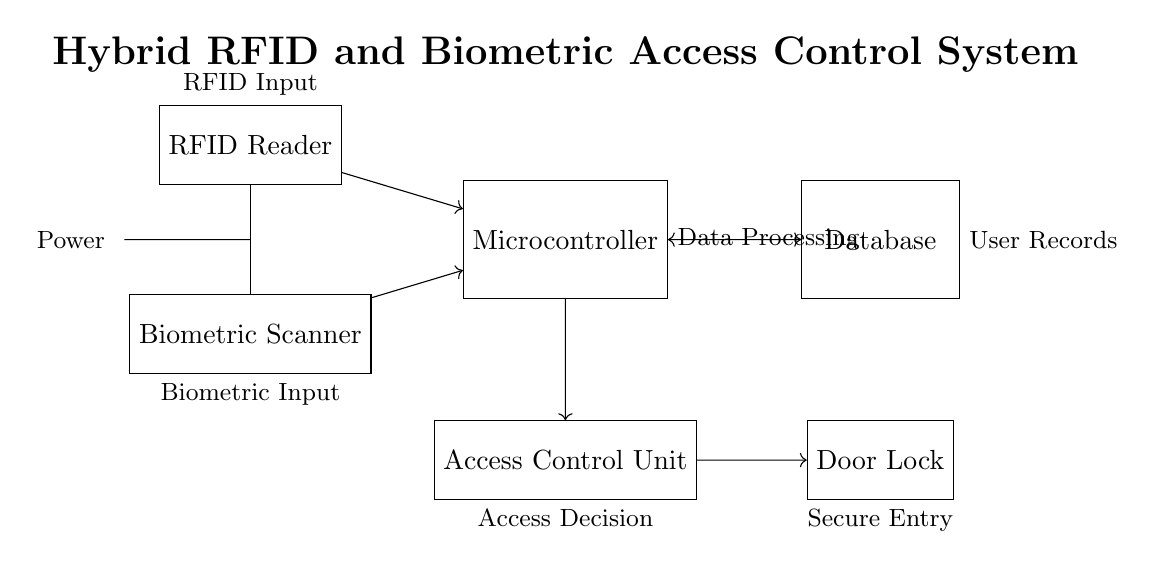What components are present in the diagram? The circuit diagram includes an RFID Reader, Biometric Scanner, Microcontroller, Database, Access Control Unit, and Door Lock. Each component plays a vital role in the hybrid access control system.
Answer: RFID Reader, Biometric Scanner, Microcontroller, Database, Access Control Unit, Door Lock What does the Microcontroller connect to? The Microcontroller connects to the RFID Reader, Biometric Scanner, Database, and Access Control Unit. The connections allow it to process inputs from the RFID and biometric devices, access user data from the database, and control access decisions through the Access Control Unit.
Answer: RFID Reader, Biometric Scanner, Database, Access Control Unit What is the role of the Access Control Unit? The Access Control Unit acts as an intermediary that makes access decisions based on the verification results from the Microcontroller. It sends the signal to the Door Lock based on the authentication outcomes.
Answer: Access decision maker Which component has bi-directional communication? The Database has bi-directional communication with the Microcontroller, allowing data retrieval and updates regarding user credentials and access permissions essential for facility management.
Answer: Database What is the function of the Door Lock in this system? The Door Lock serves as the final barrier for facility access, which is engaged or disengaged based on the decisions made by the Access Control Unit after verifying the inputs from the RFID Reader and Biometric Scanner.
Answer: Secure entry mechanism How does power supply connect to the circuit? The power supply (battery) connects to both the RFID Reader and the Biometric Scanner, providing the necessary energy for their operation. The battery output is shown leading to the components from the left side of the diagram.
Answer: Direct connection 